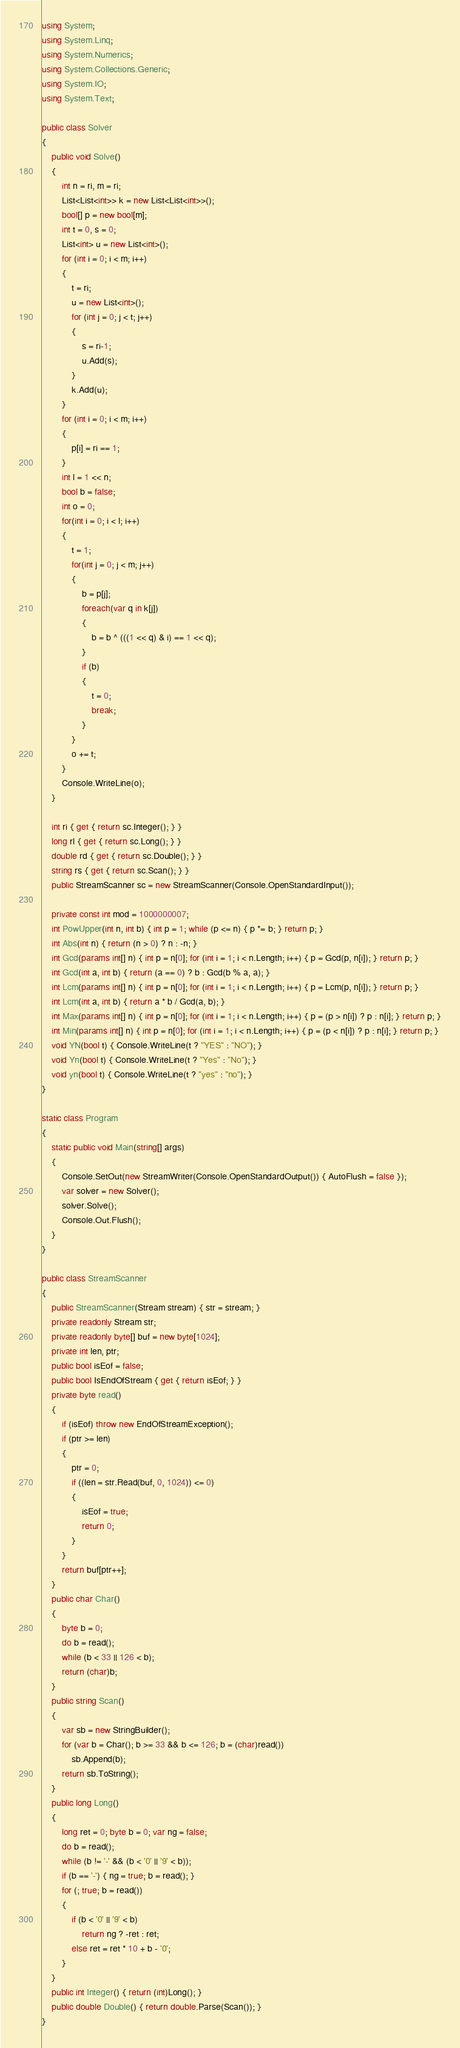Convert code to text. <code><loc_0><loc_0><loc_500><loc_500><_C#_>using System;
using System.Linq;
using System.Numerics;
using System.Collections.Generic;
using System.IO;
using System.Text;

public class Solver
{
    public void Solve()
    {
        int n = ri, m = ri;
        List<List<int>> k = new List<List<int>>();
        bool[] p = new bool[m];
        int t = 0, s = 0;
        List<int> u = new List<int>();
        for (int i = 0; i < m; i++)
        {
            t = ri;
            u = new List<int>();
            for (int j = 0; j < t; j++)
            {
                s = ri-1;
                u.Add(s);
            }
            k.Add(u);
        }
        for (int i = 0; i < m; i++)
        {
            p[i] = ri == 1;
        }
        int l = 1 << n;
        bool b = false;
        int o = 0;
        for(int i = 0; i < l; i++)
        {
            t = 1;
            for(int j = 0; j < m; j++)
            {
                b = p[j];
                foreach(var q in k[j])
                {
                    b = b ^ (((1 << q) & i) == 1 << q);
                }
                if (b)
                {
                    t = 0;
                    break;
                }
            }
            o += t;
        }
        Console.WriteLine(o);
    }

    int ri { get { return sc.Integer(); } }
    long rl { get { return sc.Long(); } }
    double rd { get { return sc.Double(); } }
    string rs { get { return sc.Scan(); } }
    public StreamScanner sc = new StreamScanner(Console.OpenStandardInput());

    private const int mod = 1000000007;
    int PowUpper(int n, int b) { int p = 1; while (p <= n) { p *= b; } return p; }
    int Abs(int n) { return (n > 0) ? n : -n; }
    int Gcd(params int[] n) { int p = n[0]; for (int i = 1; i < n.Length; i++) { p = Gcd(p, n[i]); } return p; }
    int Gcd(int a, int b) { return (a == 0) ? b : Gcd(b % a, a); }
    int Lcm(params int[] n) { int p = n[0]; for (int i = 1; i < n.Length; i++) { p = Lcm(p, n[i]); } return p; }
    int Lcm(int a, int b) { return a * b / Gcd(a, b); }
    int Max(params int[] n) { int p = n[0]; for (int i = 1; i < n.Length; i++) { p = (p > n[i]) ? p : n[i]; } return p; }
    int Min(params int[] n) { int p = n[0]; for (int i = 1; i < n.Length; i++) { p = (p < n[i]) ? p : n[i]; } return p; }
    void YN(bool t) { Console.WriteLine(t ? "YES" : "NO"); }
    void Yn(bool t) { Console.WriteLine(t ? "Yes" : "No"); }
    void yn(bool t) { Console.WriteLine(t ? "yes" : "no"); }
}

static class Program
{
    static public void Main(string[] args)
    {
        Console.SetOut(new StreamWriter(Console.OpenStandardOutput()) { AutoFlush = false });
        var solver = new Solver();
        solver.Solve();
        Console.Out.Flush();
    }
}

public class StreamScanner
{
    public StreamScanner(Stream stream) { str = stream; }
    private readonly Stream str;
    private readonly byte[] buf = new byte[1024];
    private int len, ptr;
    public bool isEof = false;
    public bool IsEndOfStream { get { return isEof; } }
    private byte read()
    {
        if (isEof) throw new EndOfStreamException();
        if (ptr >= len)
        {
            ptr = 0;
            if ((len = str.Read(buf, 0, 1024)) <= 0)
            {
                isEof = true;
                return 0;
            }
        }
        return buf[ptr++];
    }
    public char Char()
    {
        byte b = 0;
        do b = read();
        while (b < 33 || 126 < b);
        return (char)b;
    }
    public string Scan()
    {
        var sb = new StringBuilder();
        for (var b = Char(); b >= 33 && b <= 126; b = (char)read())
            sb.Append(b);
        return sb.ToString();
    }
    public long Long()
    {
        long ret = 0; byte b = 0; var ng = false;
        do b = read();
        while (b != '-' && (b < '0' || '9' < b));
        if (b == '-') { ng = true; b = read(); }
        for (; true; b = read())
        {
            if (b < '0' || '9' < b)
                return ng ? -ret : ret;
            else ret = ret * 10 + b - '0';
        }
    }
    public int Integer() { return (int)Long(); }
    public double Double() { return double.Parse(Scan()); }
}
</code> 